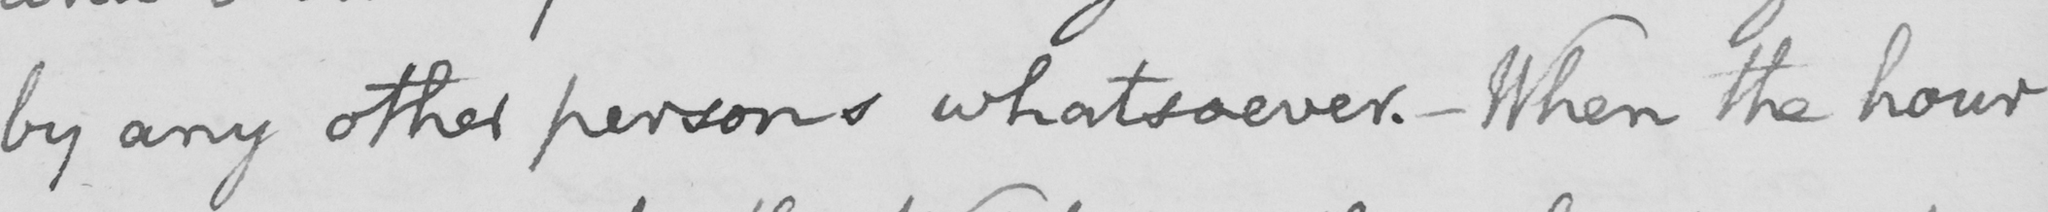What is written in this line of handwriting? by any other persons whatsoever .  _  When the hour 